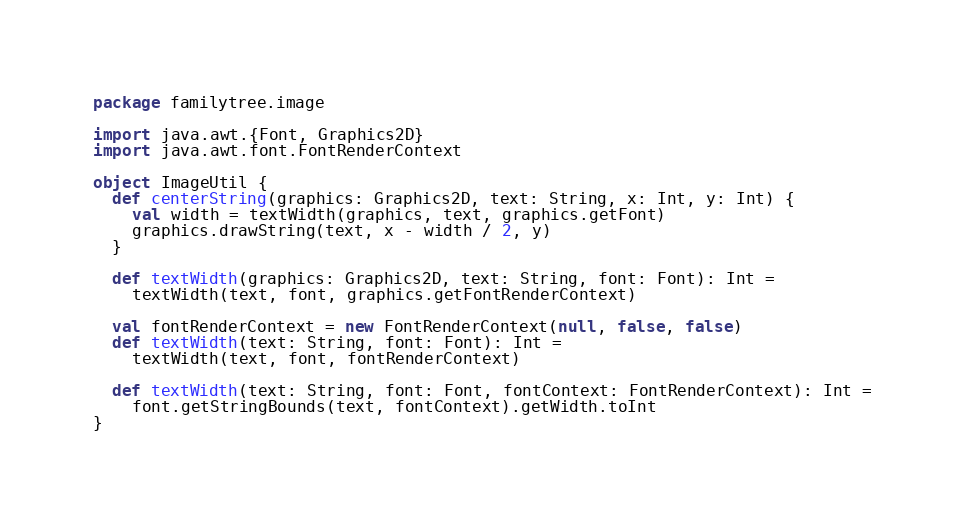Convert code to text. <code><loc_0><loc_0><loc_500><loc_500><_Scala_>package familytree.image

import java.awt.{Font, Graphics2D}
import java.awt.font.FontRenderContext

object ImageUtil {
  def centerString(graphics: Graphics2D, text: String, x: Int, y: Int) {
    val width = textWidth(graphics, text, graphics.getFont)
    graphics.drawString(text, x - width / 2, y)
  }

  def textWidth(graphics: Graphics2D, text: String, font: Font): Int =
    textWidth(text, font, graphics.getFontRenderContext)

  val fontRenderContext = new FontRenderContext(null, false, false)
  def textWidth(text: String, font: Font): Int =
    textWidth(text, font, fontRenderContext)

  def textWidth(text: String, font: Font, fontContext: FontRenderContext): Int =
    font.getStringBounds(text, fontContext).getWidth.toInt
}
</code> 